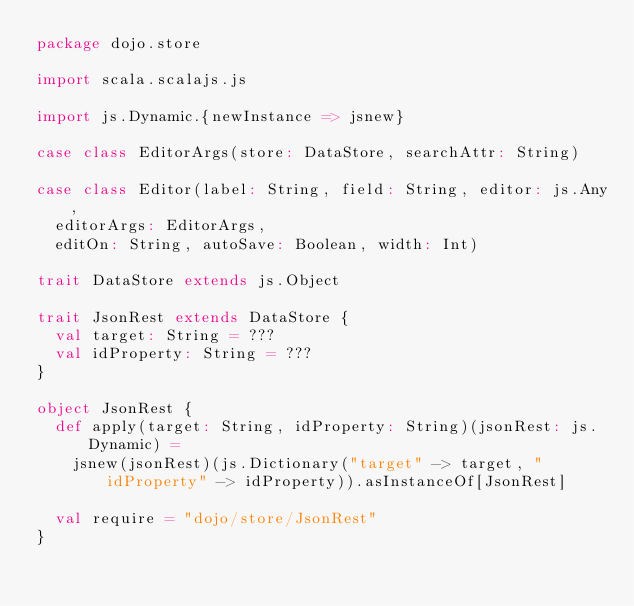<code> <loc_0><loc_0><loc_500><loc_500><_Scala_>package dojo.store

import scala.scalajs.js

import js.Dynamic.{newInstance => jsnew}

case class EditorArgs(store: DataStore, searchAttr: String)

case class Editor(label: String, field: String, editor: js.Any, 
  editorArgs: EditorArgs,
  editOn: String, autoSave: Boolean, width: Int)

trait DataStore extends js.Object

trait JsonRest extends DataStore {
  val target: String = ???
  val idProperty: String = ???
}

object JsonRest {
  def apply(target: String, idProperty: String)(jsonRest: js.Dynamic) = 
    jsnew(jsonRest)(js.Dictionary("target" -> target, "idProperty" -> idProperty)).asInstanceOf[JsonRest]

  val require = "dojo/store/JsonRest"
}
</code> 